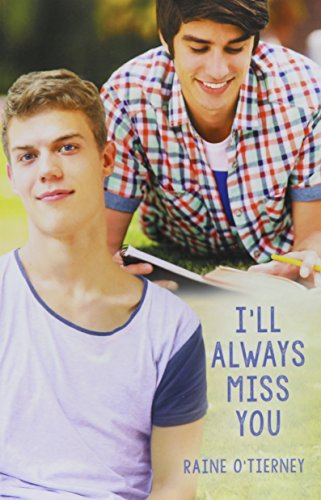Who is the author of this book? The author of this book, as indicated on the cover, is Raine O'Tierney. 